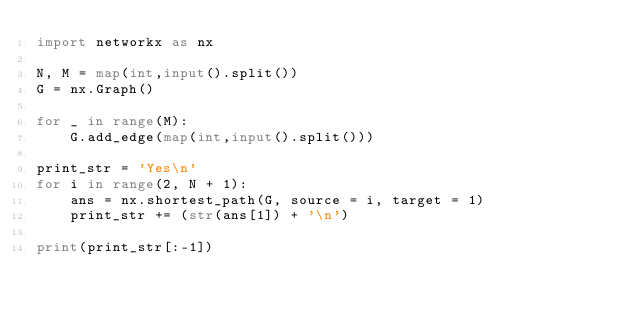<code> <loc_0><loc_0><loc_500><loc_500><_Python_>import networkx as nx

N, M = map(int,input().split())
G = nx.Graph()

for _ in range(M):
    G.add_edge(map(int,input().split()))

print_str = 'Yes\n'
for i in range(2, N + 1):
    ans = nx.shortest_path(G, source = i, target = 1)
    print_str += (str(ans[1]) + '\n')
        
print(print_str[:-1])</code> 